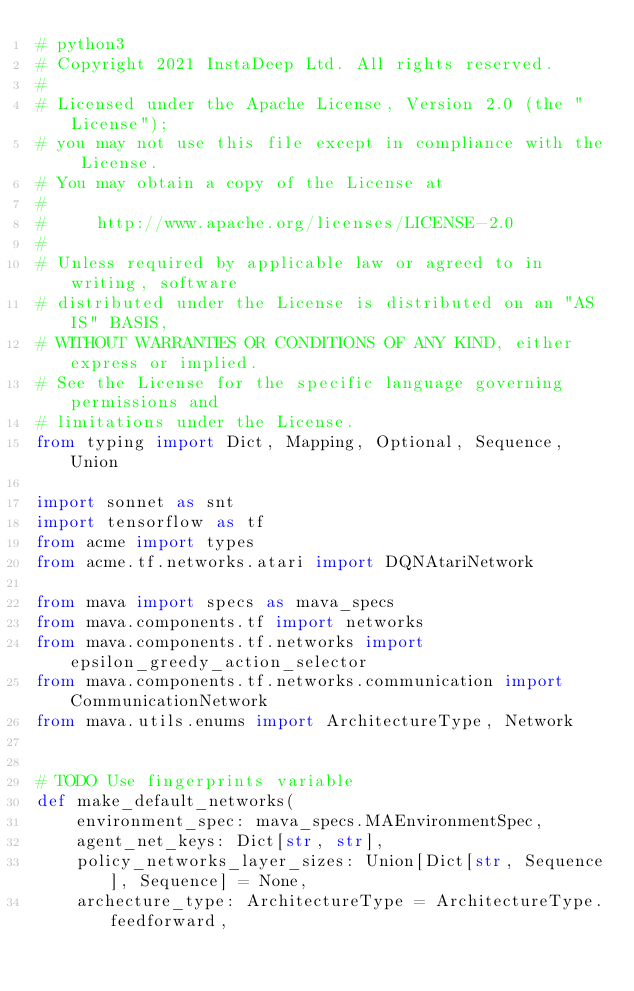Convert code to text. <code><loc_0><loc_0><loc_500><loc_500><_Python_># python3
# Copyright 2021 InstaDeep Ltd. All rights reserved.
#
# Licensed under the Apache License, Version 2.0 (the "License");
# you may not use this file except in compliance with the License.
# You may obtain a copy of the License at
#
#     http://www.apache.org/licenses/LICENSE-2.0
#
# Unless required by applicable law or agreed to in writing, software
# distributed under the License is distributed on an "AS IS" BASIS,
# WITHOUT WARRANTIES OR CONDITIONS OF ANY KIND, either express or implied.
# See the License for the specific language governing permissions and
# limitations under the License.
from typing import Dict, Mapping, Optional, Sequence, Union

import sonnet as snt
import tensorflow as tf
from acme import types
from acme.tf.networks.atari import DQNAtariNetwork

from mava import specs as mava_specs
from mava.components.tf import networks
from mava.components.tf.networks import epsilon_greedy_action_selector
from mava.components.tf.networks.communication import CommunicationNetwork
from mava.utils.enums import ArchitectureType, Network


# TODO Use fingerprints variable
def make_default_networks(
    environment_spec: mava_specs.MAEnvironmentSpec,
    agent_net_keys: Dict[str, str],
    policy_networks_layer_sizes: Union[Dict[str, Sequence], Sequence] = None,
    archecture_type: ArchitectureType = ArchitectureType.feedforward,</code> 